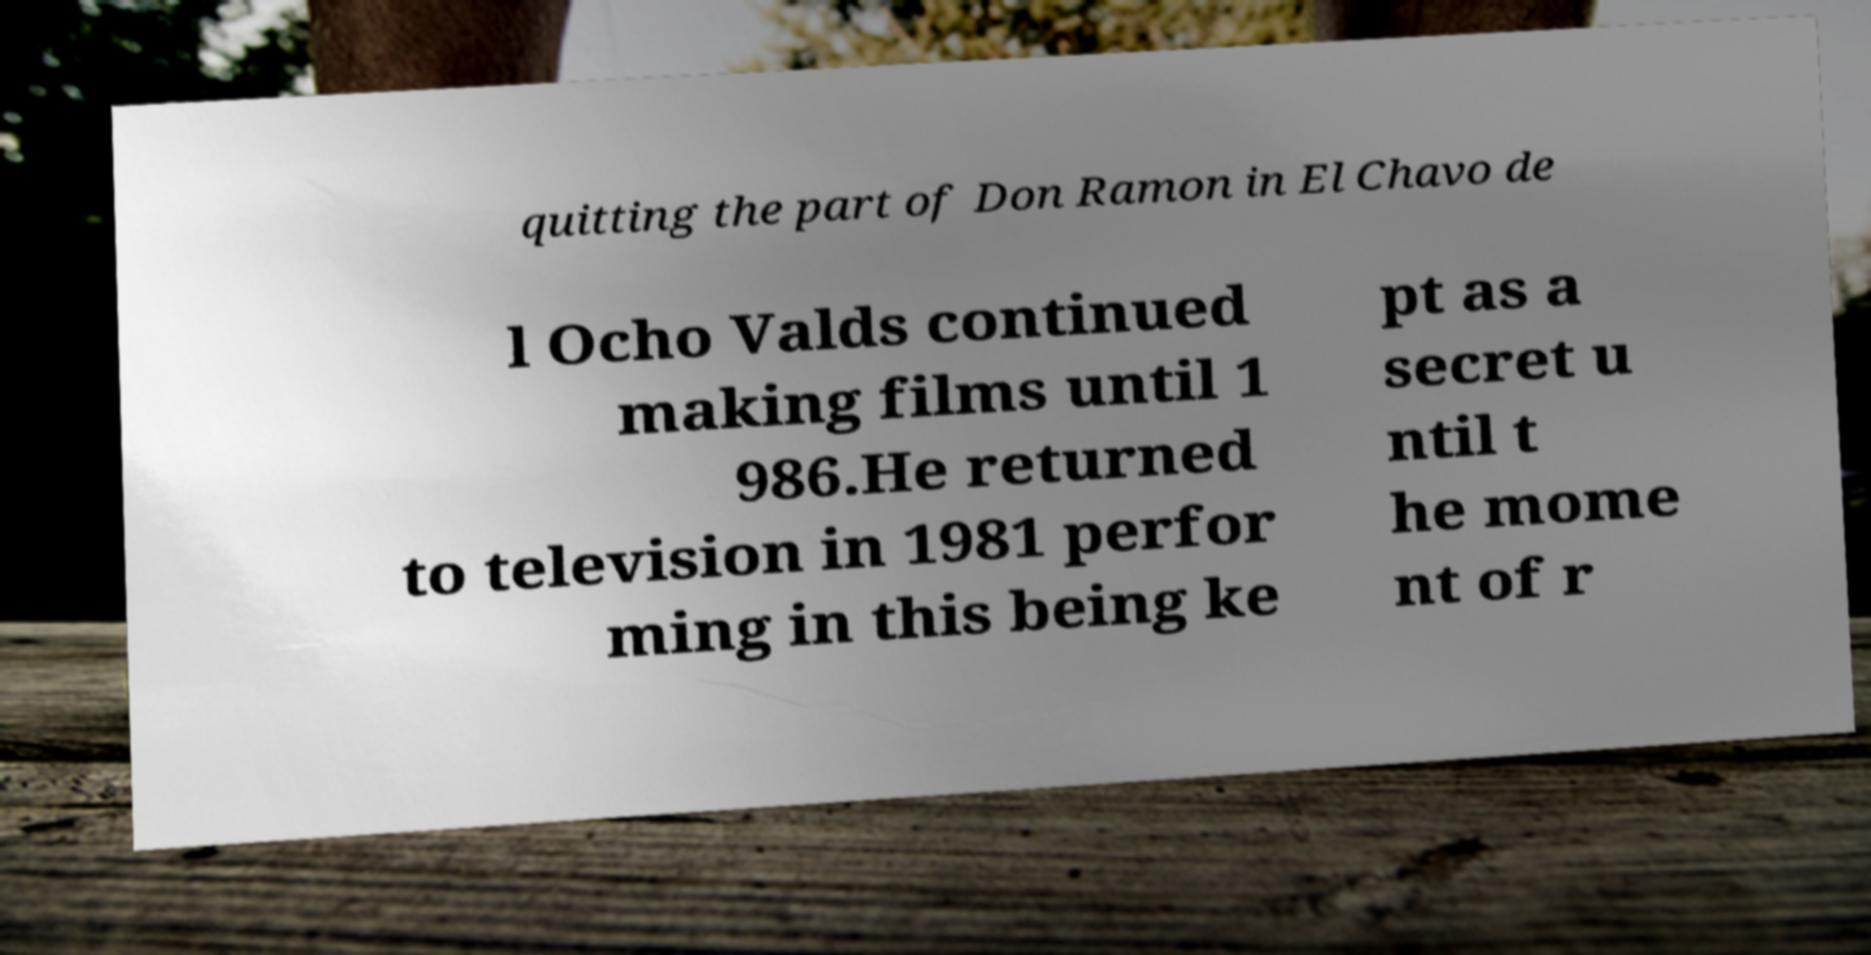Please identify and transcribe the text found in this image. quitting the part of Don Ramon in El Chavo de l Ocho Valds continued making films until 1 986.He returned to television in 1981 perfor ming in this being ke pt as a secret u ntil t he mome nt of r 